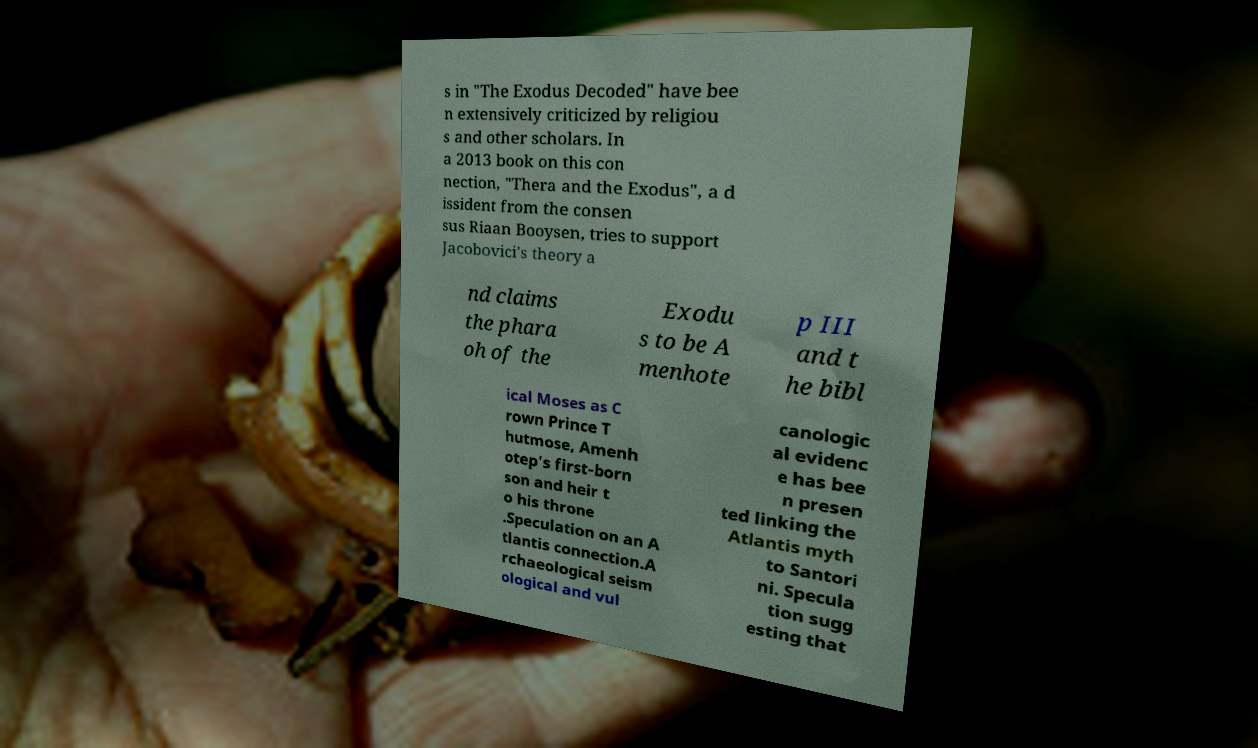For documentation purposes, I need the text within this image transcribed. Could you provide that? s in "The Exodus Decoded" have bee n extensively criticized by religiou s and other scholars. In a 2013 book on this con nection, "Thera and the Exodus", a d issident from the consen sus Riaan Booysen, tries to support Jacobovici's theory a nd claims the phara oh of the Exodu s to be A menhote p III and t he bibl ical Moses as C rown Prince T hutmose, Amenh otep's first-born son and heir t o his throne .Speculation on an A tlantis connection.A rchaeological seism ological and vul canologic al evidenc e has bee n presen ted linking the Atlantis myth to Santori ni. Specula tion sugg esting that 